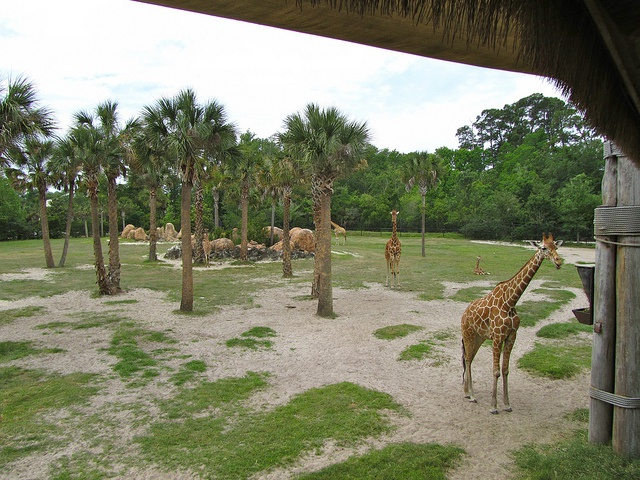Describe the objects in this image and their specific colors. I can see giraffe in white, olive, maroon, tan, and gray tones, giraffe in white, olive, gray, and maroon tones, giraffe in white, gray, olive, and tan tones, and giraffe in white, tan, and olive tones in this image. 